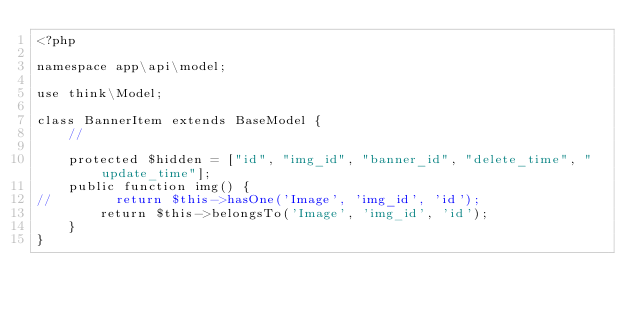<code> <loc_0><loc_0><loc_500><loc_500><_PHP_><?php

namespace app\api\model;

use think\Model;

class BannerItem extends BaseModel {
    //

    protected $hidden = ["id", "img_id", "banner_id", "delete_time", "update_time"];
    public function img() {
//        return $this->hasOne('Image', 'img_id', 'id');
        return $this->belongsTo('Image', 'img_id', 'id');
    }
}
</code> 